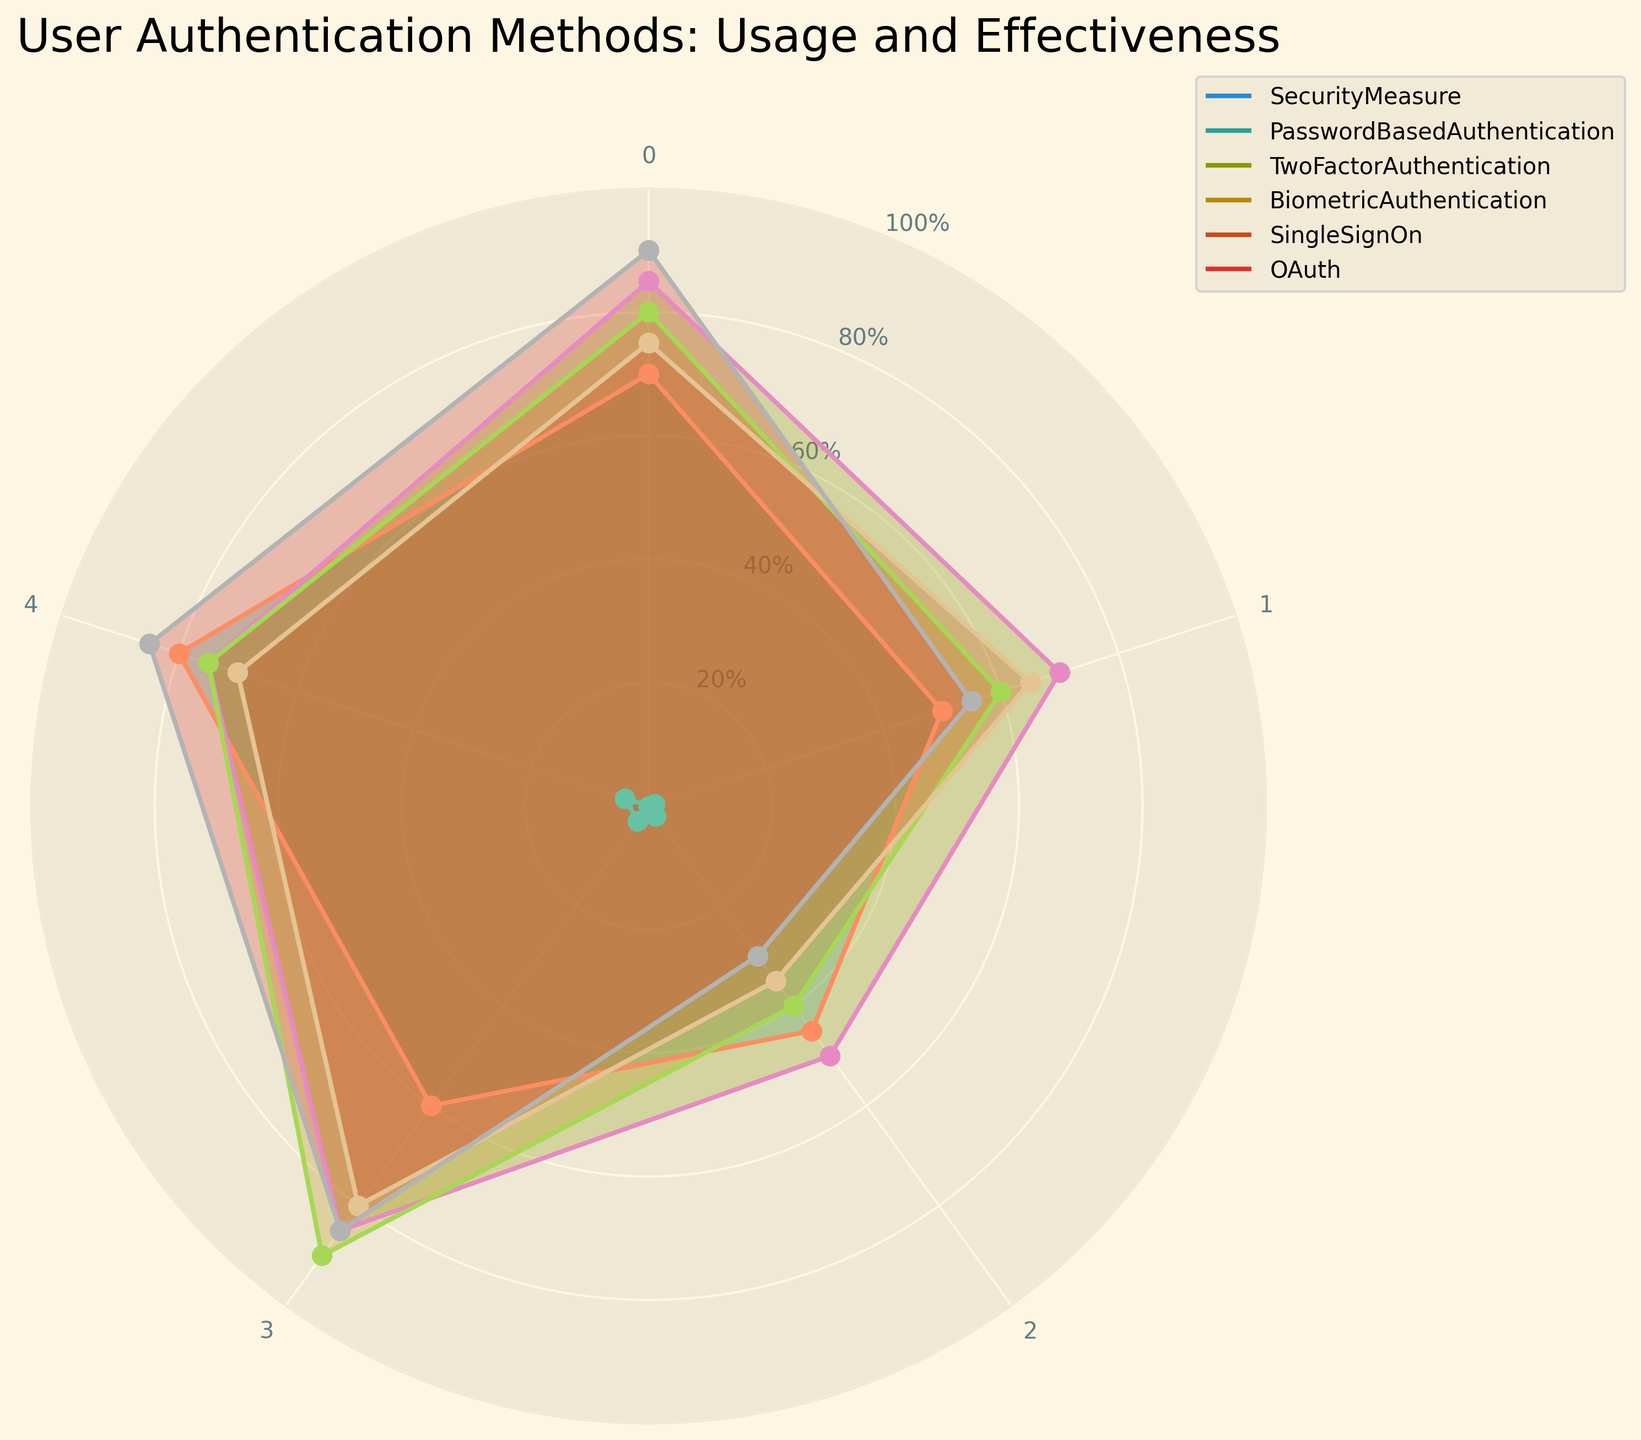Which user authentication method has the highest user satisfaction? We look for the highest value in the "User Satisfaction" category, which is under OAuth (90).
Answer: OAuth Which method has the lowest implementation complexity? We look for the lowest value in the "Implementation Complexity" category, which is found under Password-Based Authentication (50).
Answer: Password-Based Authentication What is the range of time to authenticate across all methods? The range is calculated by subtracting the minimum value from the maximum value in the "Time to Authenticate" category. The minimum is 30 (OAuth) and the maximum is 45 (Password-Based Authentication), so 45 - 30 = 15.
Answer: 15 Which user authentication method offers the most balanced performance across all categories? By comparing the consistency of the values across the five categories for each method, Biometric Authentication shows a balance with values close to each other: 80, 60, 40, 90, 75.
Answer: Biometric Authentication How does user adoption rate compare between Password-Based Authentication and Single Sign-On? The user adoption rates are 80 for Password-Based Authentication and 70 for Single Sign-On. Thus, Password-Based Authentication has a higher user adoption rate.
Answer: Password-Based Authentication is higher Which measure leads in the category of Security Effectiveness, and by how much does it surpass the second highest? Biometric Authentication leads with 90 in Security Effectiveness. The second highest is 85 (OAuth). The difference is 90 - 85 = 5.
Answer: Biometric Authentication by 5 What is the average security effectiveness across all methods? Sum the Security Effectiveness values (60+85+90+80+85)=400, and then divide by the number of methods (5), so 400/5 = 80.
Answer: 80 Which method is the fastest in terms of time to authenticate, and how does it compare to the slowest method? The fastest method is OAuth (30) and the slowest is Password-Based Authentication (45). The difference is 45-30 = 15.
Answer: OAuth faster by 15 What is the overall trend in user satisfaction among these authentication methods? Looking at the "User Satisfaction" category, the majority of methods are rated between 70 and 90, suggesting generally high user satisfaction across methods.
Answer: Generally high If you average the user adoption rates of Two-Factor Authentication and OAuth, what is the result? The user adoption rates are 75 and 85. Summing these gives 160, and dividing by 2 results in an average of 80.
Answer: 80 